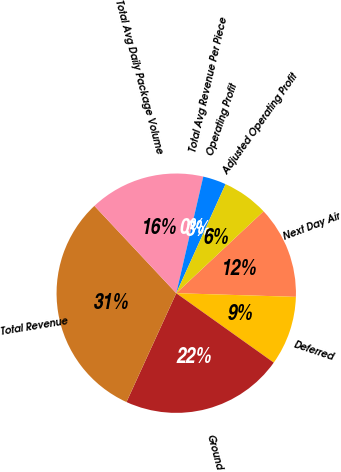Convert chart to OTSL. <chart><loc_0><loc_0><loc_500><loc_500><pie_chart><fcel>Next Day Air<fcel>Deferred<fcel>Ground<fcel>Total Revenue<fcel>Total Avg Daily Package Volume<fcel>Total Avg Revenue Per Piece<fcel>Operating Profit<fcel>Adjusted Operating Profit<nl><fcel>12.48%<fcel>9.36%<fcel>21.98%<fcel>31.19%<fcel>15.6%<fcel>0.01%<fcel>3.13%<fcel>6.25%<nl></chart> 